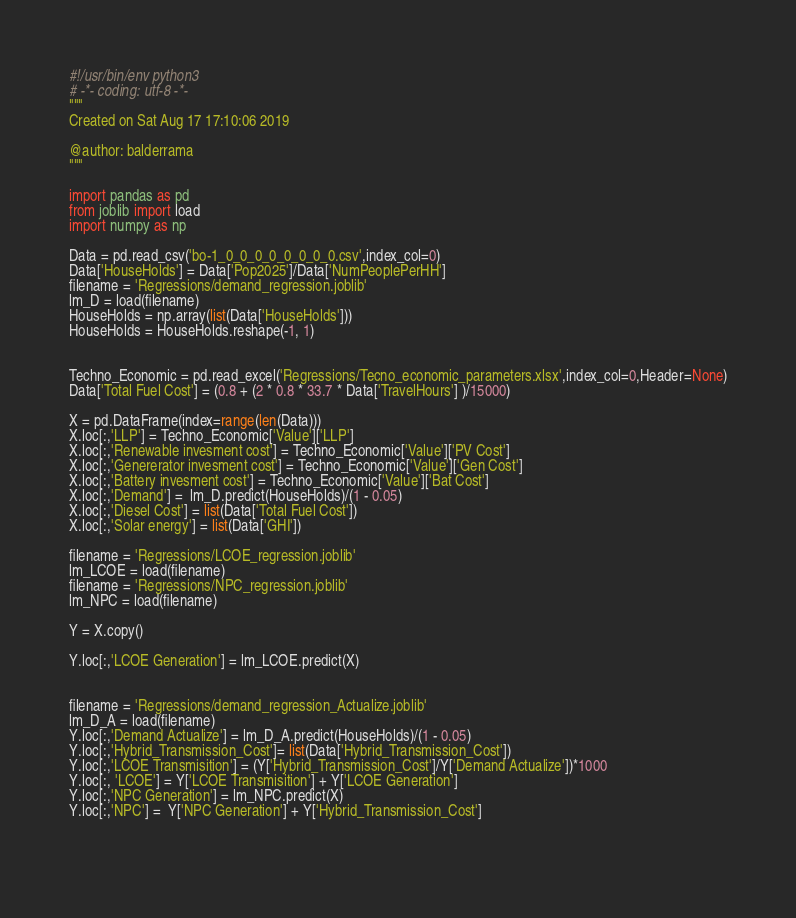<code> <loc_0><loc_0><loc_500><loc_500><_Python_>#!/usr/bin/env python3
# -*- coding: utf-8 -*-
"""
Created on Sat Aug 17 17:10:06 2019

@author: balderrama
"""

import pandas as pd
from joblib import load
import numpy as np

Data = pd.read_csv('bo-1_0_0_0_0_0_0_0_0.csv',index_col=0)    
Data['HouseHolds'] = Data['Pop2025']/Data['NumPeoplePerHH']
filename = 'Regressions/demand_regression.joblib'
lm_D = load(filename) 
HouseHolds = np.array(list(Data['HouseHolds']))
HouseHolds = HouseHolds.reshape(-1, 1)


Techno_Economic = pd.read_excel('Regressions/Tecno_economic_parameters.xlsx',index_col=0,Header=None)
Data['Total Fuel Cost'] = (0.8 + (2 * 0.8 * 33.7 * Data['TravelHours'] )/15000)     

X = pd.DataFrame(index=range(len(Data)))
X.loc[:,'LLP'] = Techno_Economic['Value']['LLP']
X.loc[:,'Renewable invesment cost'] = Techno_Economic['Value']['PV Cost']
X.loc[:,'Genererator invesment cost'] = Techno_Economic['Value']['Gen Cost']
X.loc[:,'Battery invesment cost'] = Techno_Economic['Value']['Bat Cost']
X.loc[:,'Demand'] =  lm_D.predict(HouseHolds)/(1 - 0.05)
X.loc[:,'Diesel Cost'] = list(Data['Total Fuel Cost'])
X.loc[:,'Solar energy'] = list(Data['GHI'])

filename = 'Regressions/LCOE_regression.joblib'
lm_LCOE = load(filename)   
filename = 'Regressions/NPC_regression.joblib'
lm_NPC = load(filename)  

Y = X.copy()
      
Y.loc[:,'LCOE Generation'] = lm_LCOE.predict(X)


filename = 'Regressions/demand_regression_Actualize.joblib'
lm_D_A = load(filename)
Y.loc[:,'Demand Actualize'] = lm_D_A.predict(HouseHolds)/(1 - 0.05)
Y.loc[:,'Hybrid_Transmission_Cost']= list(Data['Hybrid_Transmission_Cost'])
Y.loc[:,'LCOE Transmisition'] = (Y['Hybrid_Transmission_Cost']/Y['Demand Actualize'])*1000
Y.loc[:, 'LCOE'] = Y['LCOE Transmisition'] + Y['LCOE Generation']
Y.loc[:,'NPC Generation'] = lm_NPC.predict(X)
Y.loc[:,'NPC'] =  Y['NPC Generation'] + Y['Hybrid_Transmission_Cost']
       
 </code> 